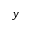<formula> <loc_0><loc_0><loc_500><loc_500>y</formula> 